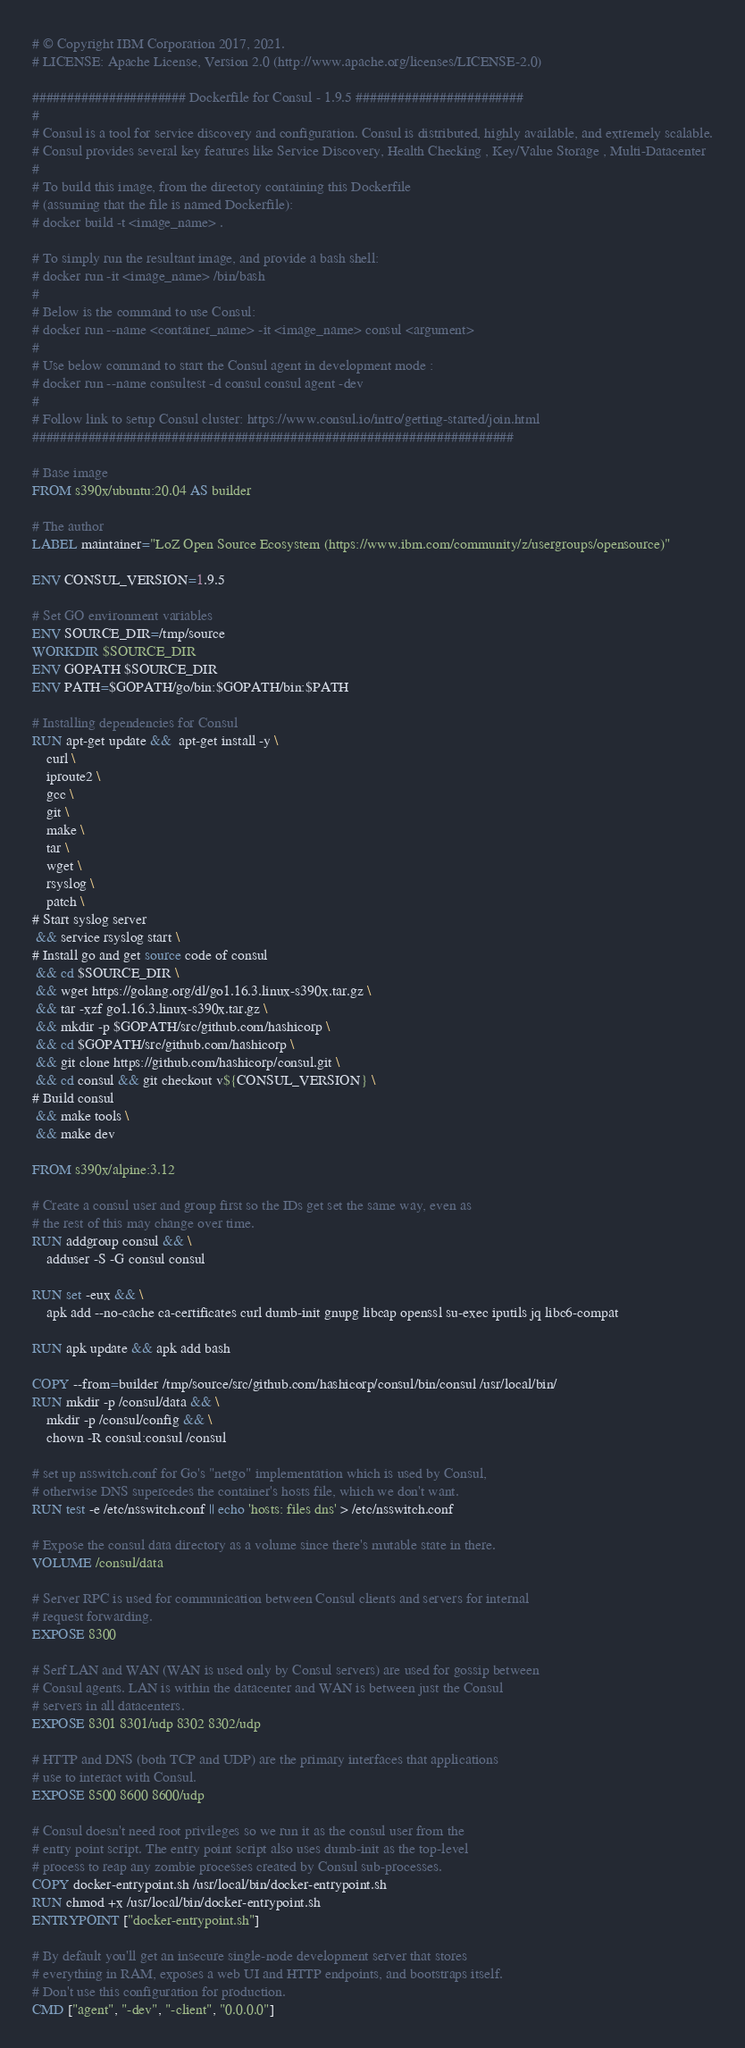<code> <loc_0><loc_0><loc_500><loc_500><_Dockerfile_># © Copyright IBM Corporation 2017, 2021.
# LICENSE: Apache License, Version 2.0 (http://www.apache.org/licenses/LICENSE-2.0)

###################### Dockerfile for Consul - 1.9.5 ########################
#
# Consul is a tool for service discovery and configuration. Consul is distributed, highly available, and extremely scalable.
# Consul provides several key features like Service Discovery, Health Checking , Key/Value Storage , Multi-Datacenter
#
# To build this image, from the directory containing this Dockerfile
# (assuming that the file is named Dockerfile):
# docker build -t <image_name> .

# To simply run the resultant image, and provide a bash shell:
# docker run -it <image_name> /bin/bash
#
# Below is the command to use Consul:
# docker run --name <container_name> -it <image_name> consul <argument>
#
# Use below command to start the Consul agent in development mode :
# docker run --name consultest -d consul consul agent -dev
#
# Follow link to setup Consul cluster: https://www.consul.io/intro/getting-started/join.html
#####################################################################

# Base image
FROM s390x/ubuntu:20.04 AS builder

# The author
LABEL maintainer="LoZ Open Source Ecosystem (https://www.ibm.com/community/z/usergroups/opensource)"

ENV CONSUL_VERSION=1.9.5

# Set GO environment variables
ENV SOURCE_DIR=/tmp/source
WORKDIR $SOURCE_DIR
ENV GOPATH $SOURCE_DIR
ENV PATH=$GOPATH/go/bin:$GOPATH/bin:$PATH

# Installing dependencies for Consul
RUN apt-get update &&  apt-get install -y \
    curl \
    iproute2 \
    gcc \
    git \
    make \
    tar \
    wget \
    rsyslog \
    patch \
# Start syslog server
 && service rsyslog start \
# Install go and get source code of consul
 && cd $SOURCE_DIR \
 && wget https://golang.org/dl/go1.16.3.linux-s390x.tar.gz \
 && tar -xzf go1.16.3.linux-s390x.tar.gz \
 && mkdir -p $GOPATH/src/github.com/hashicorp \
 && cd $GOPATH/src/github.com/hashicorp \
 && git clone https://github.com/hashicorp/consul.git \
 && cd consul && git checkout v${CONSUL_VERSION} \
# Build consul
 && make tools \
 && make dev

FROM s390x/alpine:3.12

# Create a consul user and group first so the IDs get set the same way, even as
# the rest of this may change over time.
RUN addgroup consul && \
    adduser -S -G consul consul

RUN set -eux && \
    apk add --no-cache ca-certificates curl dumb-init gnupg libcap openssl su-exec iputils jq libc6-compat

RUN apk update && apk add bash

COPY --from=builder /tmp/source/src/github.com/hashicorp/consul/bin/consul /usr/local/bin/
RUN mkdir -p /consul/data && \
    mkdir -p /consul/config && \
    chown -R consul:consul /consul

# set up nsswitch.conf for Go's "netgo" implementation which is used by Consul,
# otherwise DNS supercedes the container's hosts file, which we don't want.
RUN test -e /etc/nsswitch.conf || echo 'hosts: files dns' > /etc/nsswitch.conf

# Expose the consul data directory as a volume since there's mutable state in there.
VOLUME /consul/data

# Server RPC is used for communication between Consul clients and servers for internal
# request forwarding.
EXPOSE 8300

# Serf LAN and WAN (WAN is used only by Consul servers) are used for gossip between
# Consul agents. LAN is within the datacenter and WAN is between just the Consul
# servers in all datacenters.
EXPOSE 8301 8301/udp 8302 8302/udp

# HTTP and DNS (both TCP and UDP) are the primary interfaces that applications
# use to interact with Consul.
EXPOSE 8500 8600 8600/udp

# Consul doesn't need root privileges so we run it as the consul user from the
# entry point script. The entry point script also uses dumb-init as the top-level
# process to reap any zombie processes created by Consul sub-processes.
COPY docker-entrypoint.sh /usr/local/bin/docker-entrypoint.sh
RUN chmod +x /usr/local/bin/docker-entrypoint.sh
ENTRYPOINT ["docker-entrypoint.sh"]

# By default you'll get an insecure single-node development server that stores
# everything in RAM, exposes a web UI and HTTP endpoints, and bootstraps itself.
# Don't use this configuration for production.
CMD ["agent", "-dev", "-client", "0.0.0.0"]
</code> 